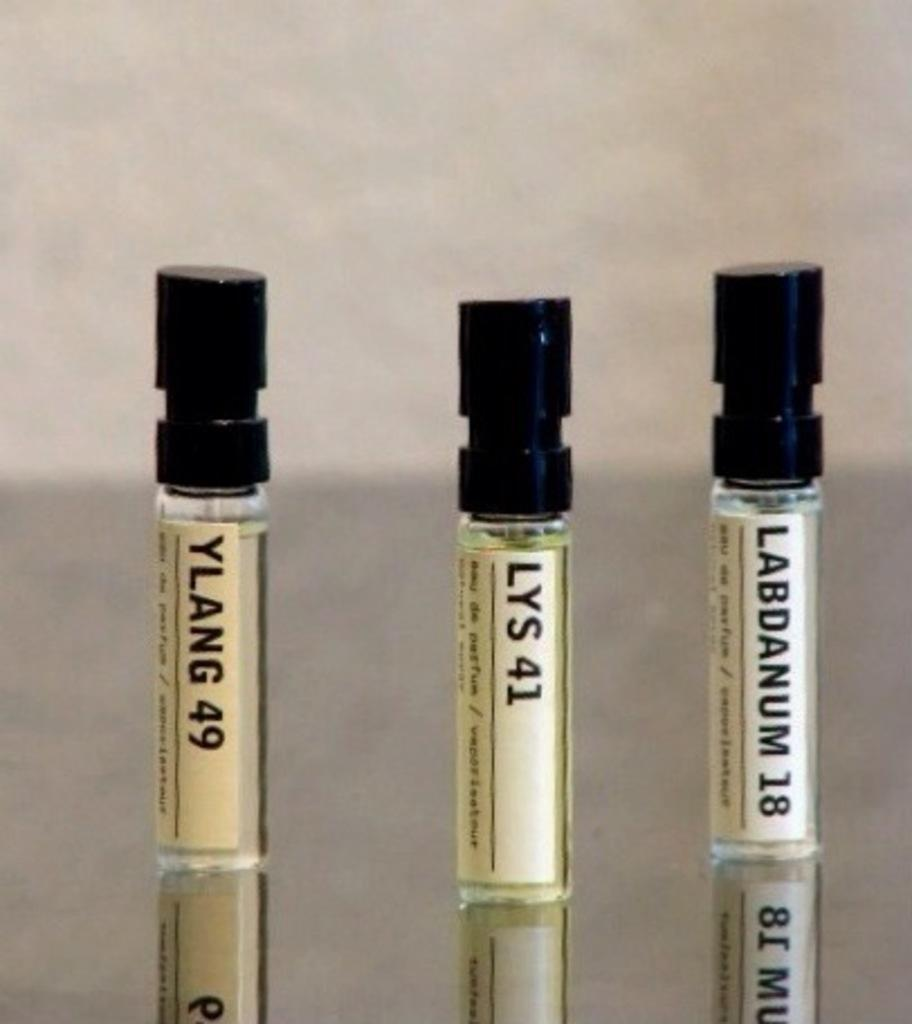<image>
Present a compact description of the photo's key features. Three different fragrances one in the middle called LYS 41 